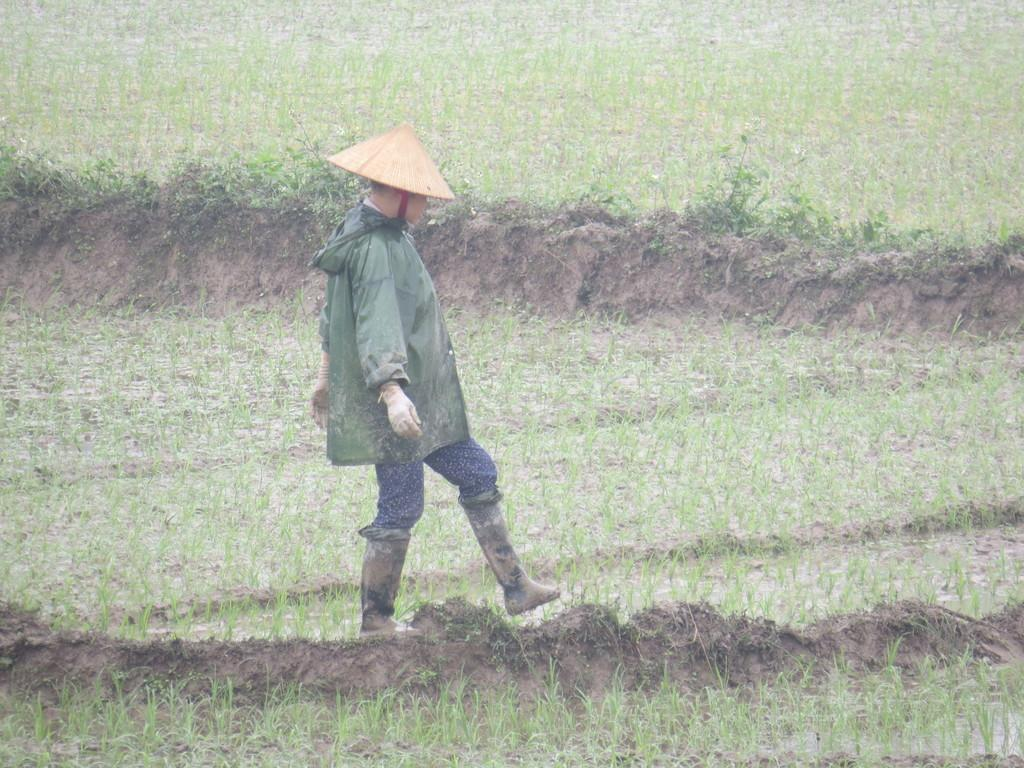What is the main setting of the image? There is a field in the image. What can be found in the middle of the field? There is a statue in the middle of the field. What is the statue wearing on its head? The statue is wearing a cap. What color is the jacket that the statue is wearing? The statue is wearing a grey color jacket. How many dinosaurs can be seen grazing in the field in the image? There are no dinosaurs present in the image; it features a field with a statue wearing a cap and a grey color jacket. What type of calendar is hanging on the statue's arm in the image? There is no calendar present in the image; the statue is wearing a cap and a grey color jacket. 